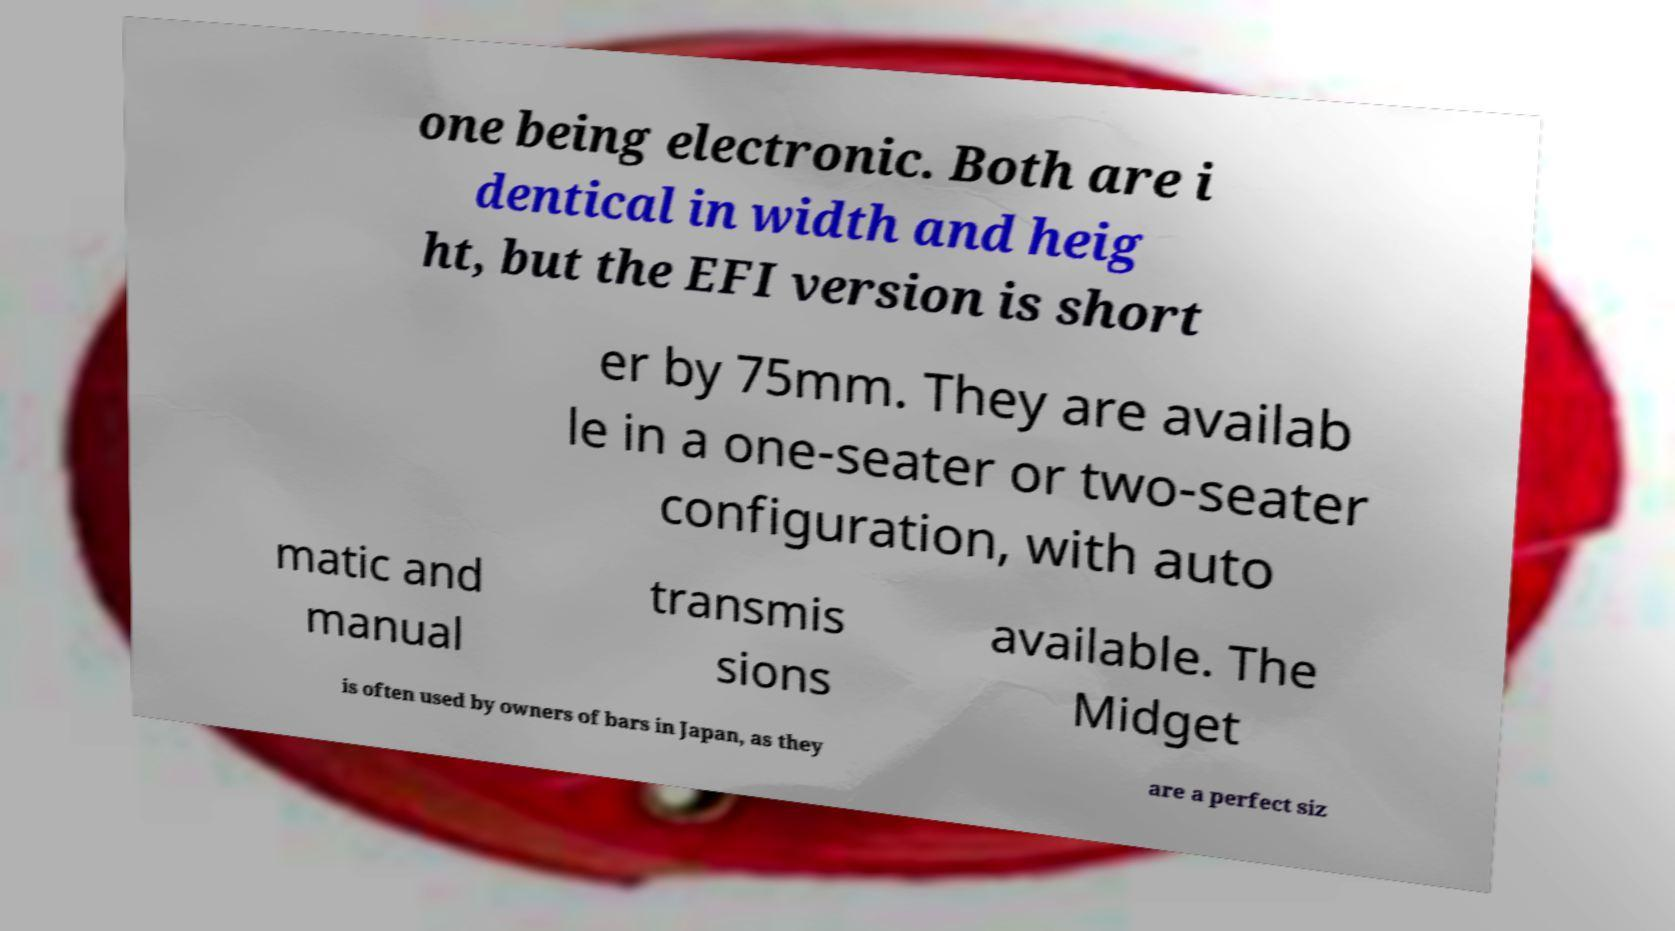There's text embedded in this image that I need extracted. Can you transcribe it verbatim? one being electronic. Both are i dentical in width and heig ht, but the EFI version is short er by 75mm. They are availab le in a one-seater or two-seater configuration, with auto matic and manual transmis sions available. The Midget is often used by owners of bars in Japan, as they are a perfect siz 